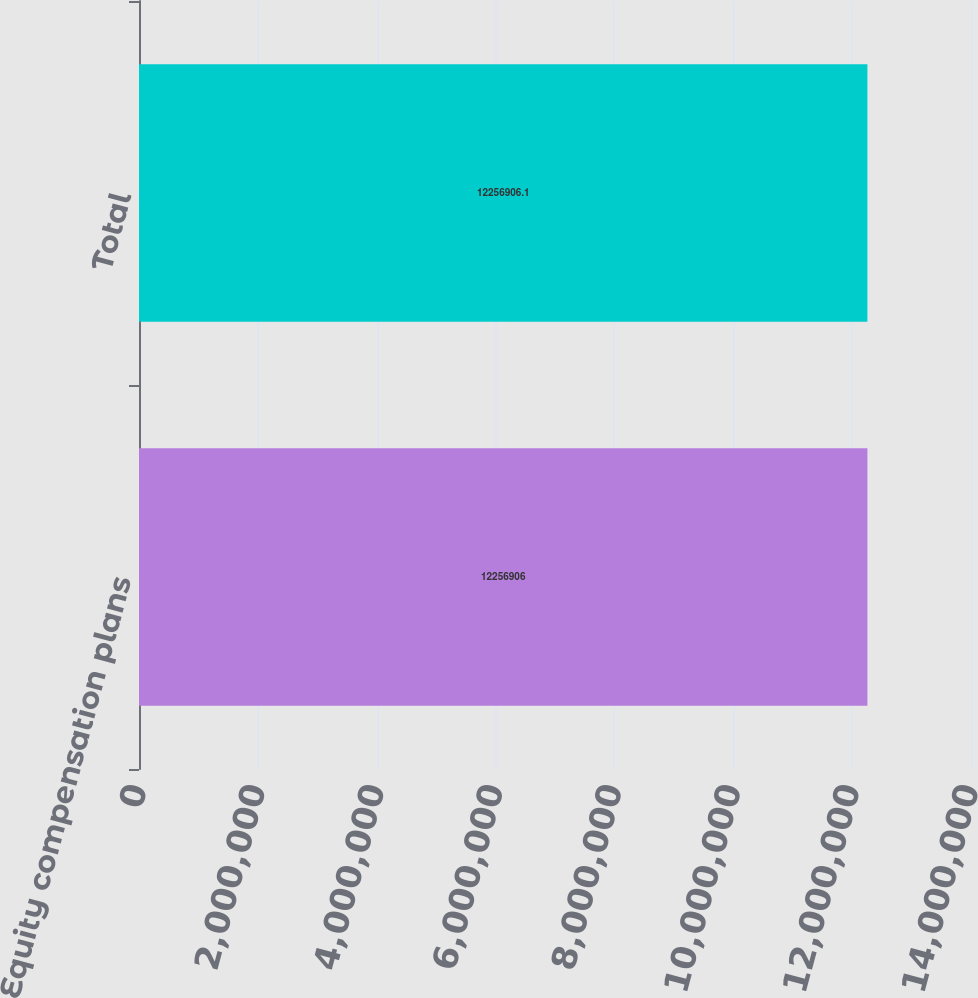Convert chart. <chart><loc_0><loc_0><loc_500><loc_500><bar_chart><fcel>Equity compensation plans<fcel>Total<nl><fcel>1.22569e+07<fcel>1.22569e+07<nl></chart> 